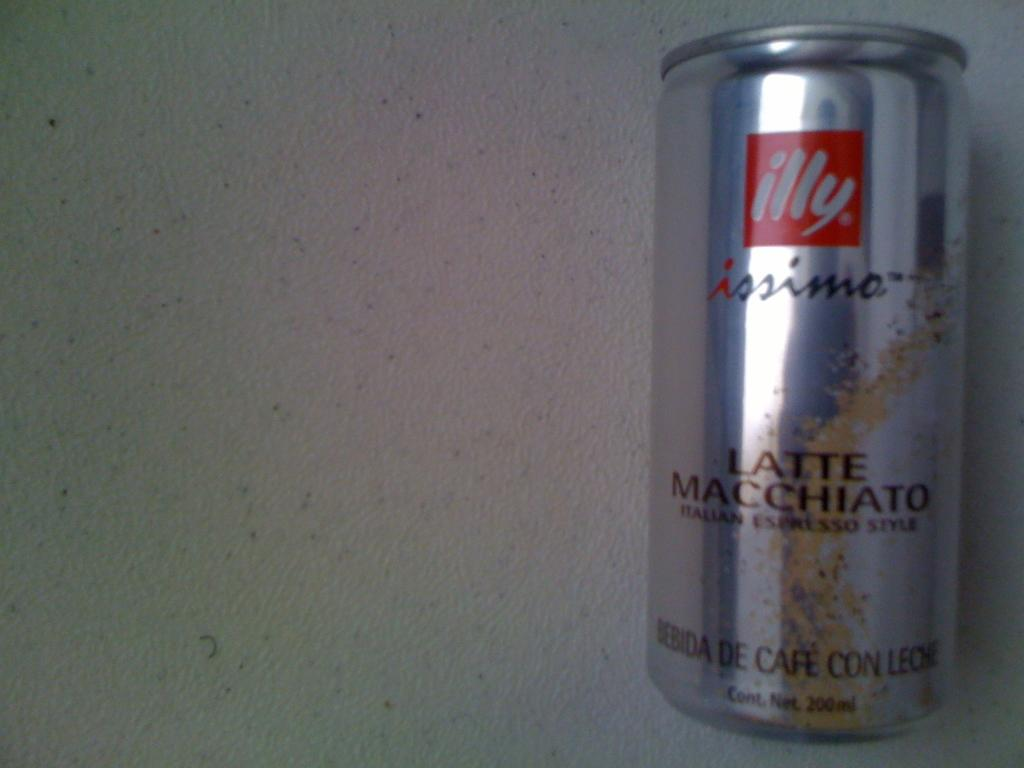Provide a one-sentence caption for the provided image. A can of illy brand latte macchiato sits on a white table. 